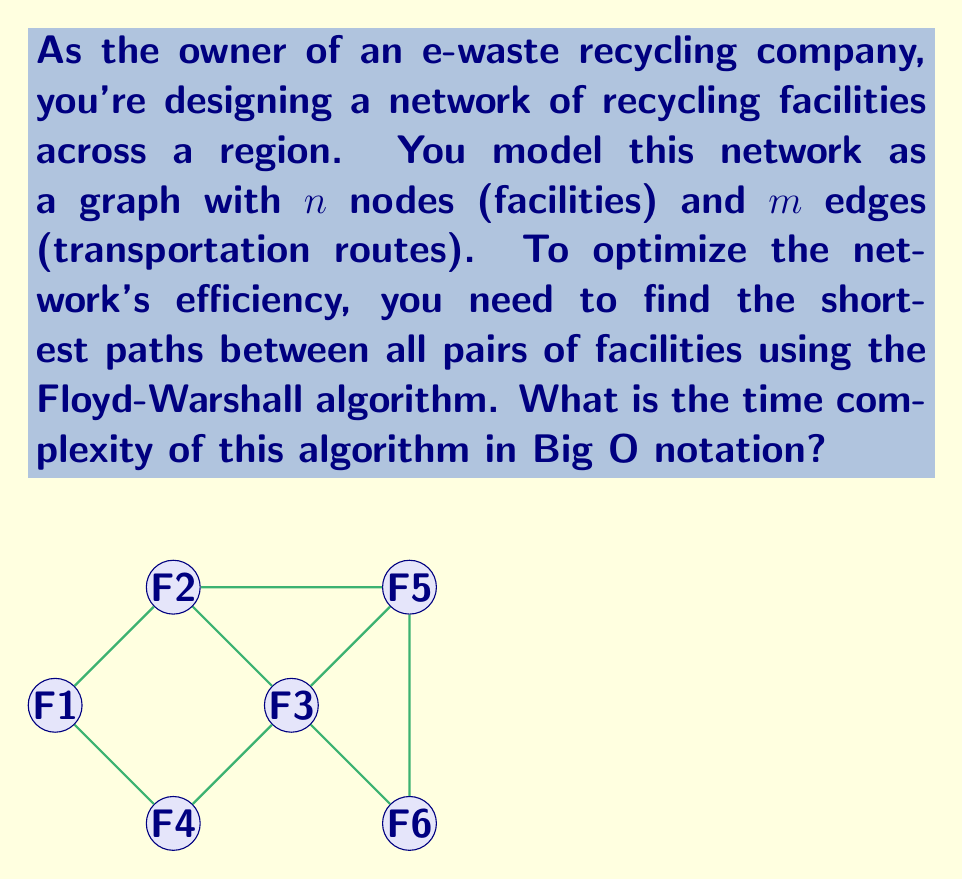Teach me how to tackle this problem. To determine the time complexity of the Floyd-Warshall algorithm, let's analyze its structure:

1. The algorithm uses three nested loops, each iterating over all nodes in the graph:
   $$\text{for } k = 1 \text{ to } n$$
   $$\quad \text{for } i = 1 \text{ to } n$$
   $$\quad \quad \text{for } j = 1 \text{ to } n$$

2. Inside these loops, we perform a constant-time operation:
   $$\text{if } \text{dist}[i][j] > \text{dist}[i][k] + \text{dist}[k][j]$$
   $$\quad \text{dist}[i][j] = \text{dist}[i][k] + \text{dist}[k][j]$$

3. The number of iterations for each loop is $n$, so we have $n \times n \times n = n^3$ total iterations.

4. Since the operation inside the loops takes constant time, we multiply this by a constant factor $c$.

5. Therefore, the total runtime is $c \times n^3$.

6. In Big O notation, we drop constant factors and lower-order terms, leaving us with $O(n^3)$.

It's important to note that this time complexity is independent of the number of edges $m$ in the graph, as the Floyd-Warshall algorithm considers all possible paths between each pair of nodes, regardless of whether a direct edge exists between them.
Answer: $O(n^3)$ 